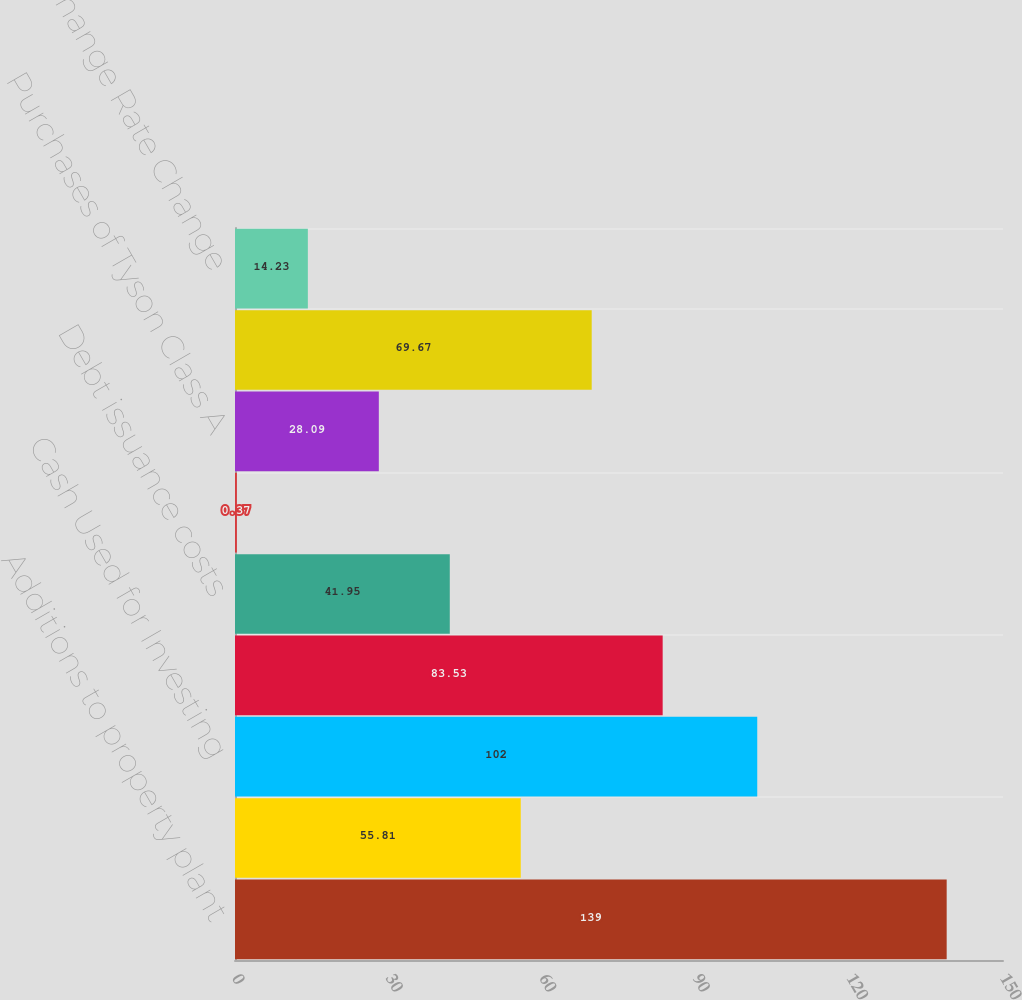<chart> <loc_0><loc_0><loc_500><loc_500><bar_chart><fcel>Additions to property plant<fcel>Purchases of marketable<fcel>Cash Used for Investing<fcel>Net change in debt<fcel>Debt issuance costs<fcel>Purchase of redeemable<fcel>Purchases of Tyson Class A<fcel>Other net<fcel>Effect of Exchange Rate Change<nl><fcel>139<fcel>55.81<fcel>102<fcel>83.53<fcel>41.95<fcel>0.37<fcel>28.09<fcel>69.67<fcel>14.23<nl></chart> 